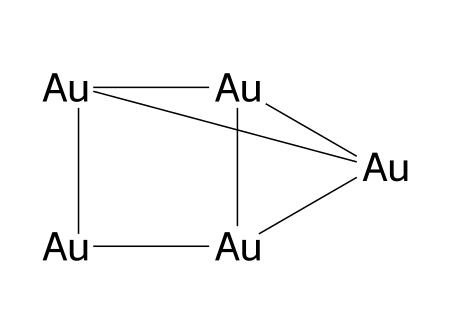what is the chemical name represented by this structure? The SMILES representation includes gold atoms, which corresponds to the chemical name gold.
Answer: gold how many gold atoms are present in the structure? The SMILES notation indicates a total of five gold atoms present in the structure.
Answer: 5 what is the crystalline structure of gold in bullion bars? The crystalline structure of gold is cubic face-centered, which is typical for metals like gold in elemental form.
Answer: cubic face-centered what type of solid is gold categorized as? Gold is categorized as a metallic solid due to its conductive properties and metallic bonding.
Answer: metallic solid what feature indicates that gold in this structure is a pure element? The consistent presence of only gold atoms with no other elements in the SMILES confirms that it is a pure element.
Answer: pure element how does the crystalline structure of gold affect its malleability? The face-centered cubic structure allows layers of atoms to move easily, resulting in high malleability.
Answer: high malleability which bonding type is predominant in the structure of gold? The predominant bonding type in gold is metallic bonding, which is characterized by a sea of delocalized electrons.
Answer: metallic bonding 